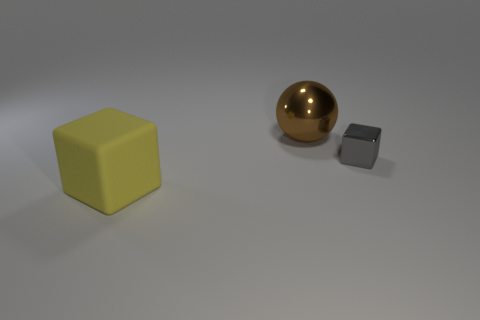Are there any other things that are the same color as the big metallic ball?
Give a very brief answer. No. There is a cube that is right of the big brown metallic ball that is left of the small cube; what is its material?
Give a very brief answer. Metal. There is a big thing in front of the gray shiny object; does it have the same shape as the gray metallic object?
Keep it short and to the point. Yes. Is the number of yellow objects that are in front of the gray cube greater than the number of large yellow rubber spheres?
Your response must be concise. Yes. Is there anything else that has the same material as the large yellow cube?
Your response must be concise. No. How many spheres are either matte things or gray things?
Your response must be concise. 0. There is a cube that is to the left of the cube on the right side of the yellow rubber cube; what color is it?
Offer a very short reply. Yellow. What size is the gray block that is made of the same material as the brown ball?
Give a very brief answer. Small. Are there any yellow cubes to the right of the metallic thing to the left of the cube behind the yellow rubber cube?
Offer a very short reply. No. What number of metal balls have the same size as the gray shiny object?
Your answer should be very brief. 0. 